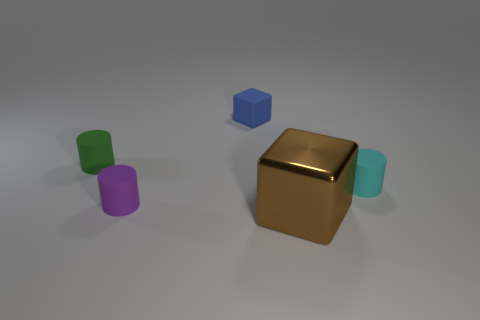Are there any other things that have the same material as the large brown object?
Ensure brevity in your answer.  No. Is the number of big red cylinders greater than the number of small cyan matte things?
Ensure brevity in your answer.  No. There is a brown metallic block that is in front of the thing behind the green cylinder; how big is it?
Provide a short and direct response. Large. There is a cyan object that is the same size as the purple object; what shape is it?
Give a very brief answer. Cylinder. What is the shape of the big thing that is to the right of the small matte cylinder that is in front of the small cylinder that is on the right side of the brown thing?
Give a very brief answer. Cube. How many small cyan metallic spheres are there?
Ensure brevity in your answer.  0. Are there any small matte cylinders behind the purple cylinder?
Keep it short and to the point. Yes. Is the material of the cylinder right of the big brown cube the same as the cylinder that is left of the small purple thing?
Offer a very short reply. Yes. Are there fewer big brown objects that are in front of the shiny block than big yellow metallic cubes?
Your response must be concise. No. The rubber cylinder left of the purple rubber cylinder is what color?
Keep it short and to the point. Green. 